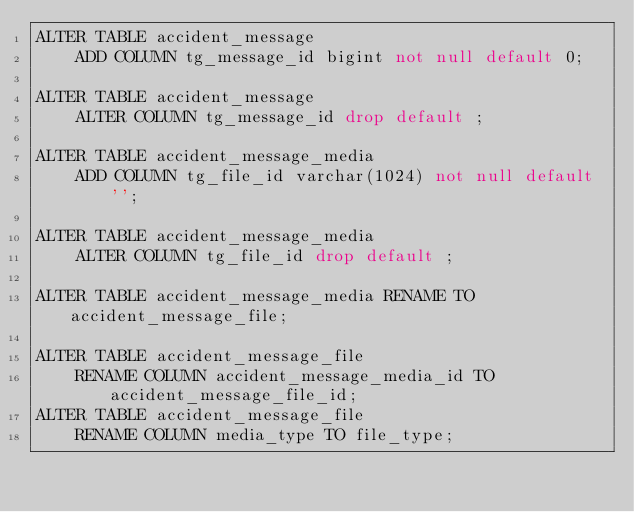<code> <loc_0><loc_0><loc_500><loc_500><_SQL_>ALTER TABLE accident_message
    ADD COLUMN tg_message_id bigint not null default 0;

ALTER TABLE accident_message
    ALTER COLUMN tg_message_id drop default ;

ALTER TABLE accident_message_media
    ADD COLUMN tg_file_id varchar(1024) not null default '';

ALTER TABLE accident_message_media
    ALTER COLUMN tg_file_id drop default ;

ALTER TABLE accident_message_media RENAME TO accident_message_file;

ALTER TABLE accident_message_file
    RENAME COLUMN accident_message_media_id TO accident_message_file_id;
ALTER TABLE accident_message_file
    RENAME COLUMN media_type TO file_type;
</code> 